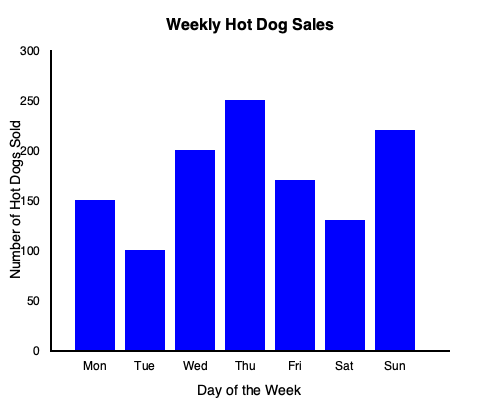Based on the bar graph showing weekly hot dog sales, calculate the total number of hot dogs you should prepare for the upcoming week if you want to have a 15% buffer to account for potential increased demand during a highly anticipated basketball game. Round your answer to the nearest whole number. To solve this problem, we'll follow these steps:

1. Calculate the total number of hot dogs sold in the current week:
   Monday: 150
   Tuesday: 100
   Wednesday: 200
   Thursday: 250
   Friday: 170
   Saturday: 130
   Sunday: 220
   
   Total = $150 + 100 + 200 + 250 + 170 + 130 + 220 = 1220$ hot dogs

2. Calculate the 15% buffer:
   $15\% \text{ of } 1220 = 0.15 \times 1220 = 183$ hot dogs

3. Add the buffer to the total:
   $1220 + 183 = 1403$ hot dogs

4. Round to the nearest whole number:
   1403 rounds to 1403 (it's already a whole number)

Therefore, you should prepare 1403 hot dogs for the upcoming week to account for the potential increased demand during the highly anticipated basketball game.
Answer: 1403 hot dogs 